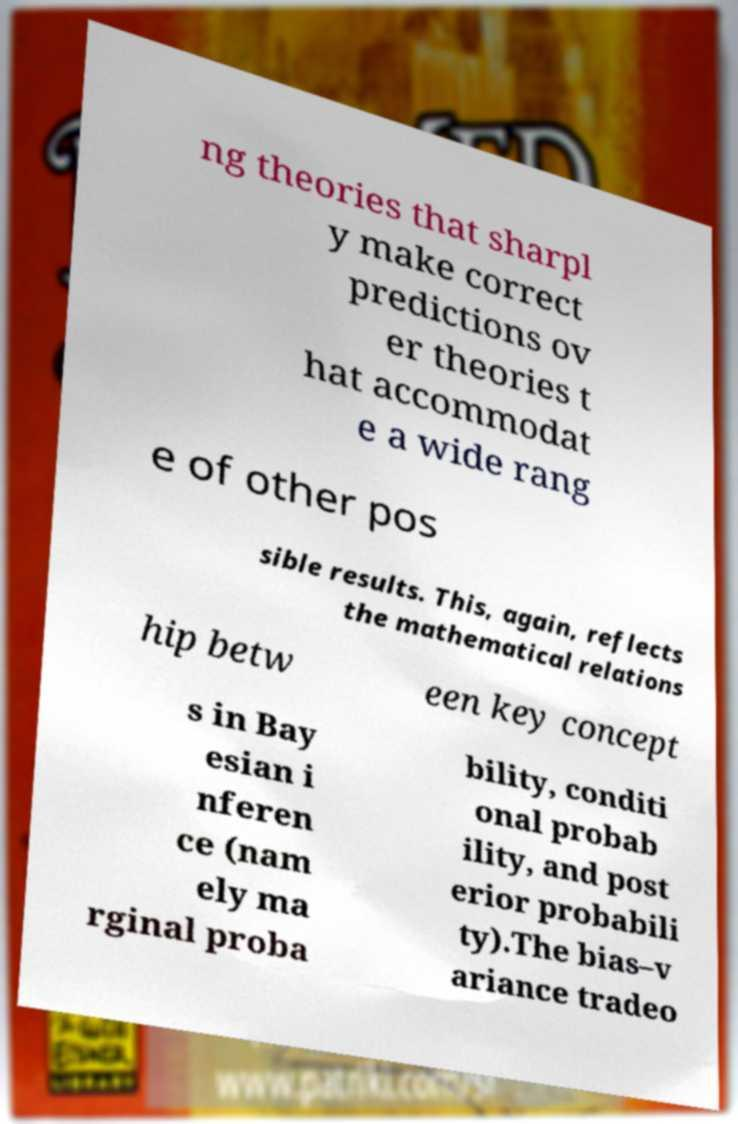I need the written content from this picture converted into text. Can you do that? ng theories that sharpl y make correct predictions ov er theories t hat accommodat e a wide rang e of other pos sible results. This, again, reflects the mathematical relations hip betw een key concept s in Bay esian i nferen ce (nam ely ma rginal proba bility, conditi onal probab ility, and post erior probabili ty).The bias–v ariance tradeo 